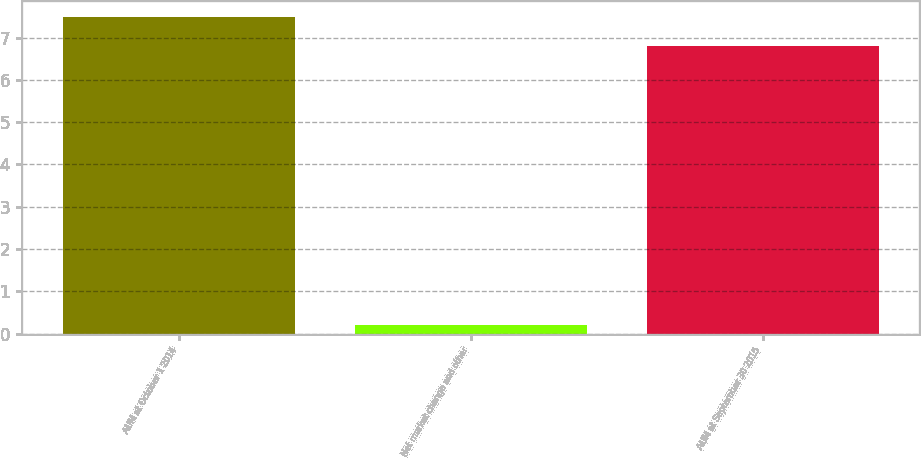Convert chart. <chart><loc_0><loc_0><loc_500><loc_500><bar_chart><fcel>AUM at October 1 2014<fcel>Net market change and other<fcel>AUM at September 30 2015<nl><fcel>7.48<fcel>0.2<fcel>6.8<nl></chart> 